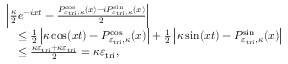<formula> <loc_0><loc_0><loc_500><loc_500>\begin{array} { r l } & { \left | \frac { \kappa } { 2 } e ^ { - i x t } - \frac { P _ { \varepsilon _ { t r i } , \kappa } ^ { \cos } ( x ) - i P _ { \varepsilon _ { t r i } , \kappa } ^ { \sin } ( x ) } { 2 } \right | } \\ & { \quad \leq \frac { 1 } { 2 } \left | \kappa \cos ( x t ) - P _ { \varepsilon _ { t r i } , \kappa } ^ { \cos } ( x ) \right | + \frac { 1 } { 2 } \left | \kappa \sin ( x t ) - P _ { \varepsilon _ { t r i } , \kappa } ^ { \sin } ( x ) \right | } \\ & { \quad \leq \frac { \kappa \varepsilon _ { t r i } + \kappa \varepsilon _ { t r i } } { 2 } = \kappa \varepsilon _ { t r i } , } \end{array}</formula> 